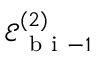Convert formula to latex. <formula><loc_0><loc_0><loc_500><loc_500>\mathcal { E } _ { b i - 1 } ^ { ( 2 ) }</formula> 